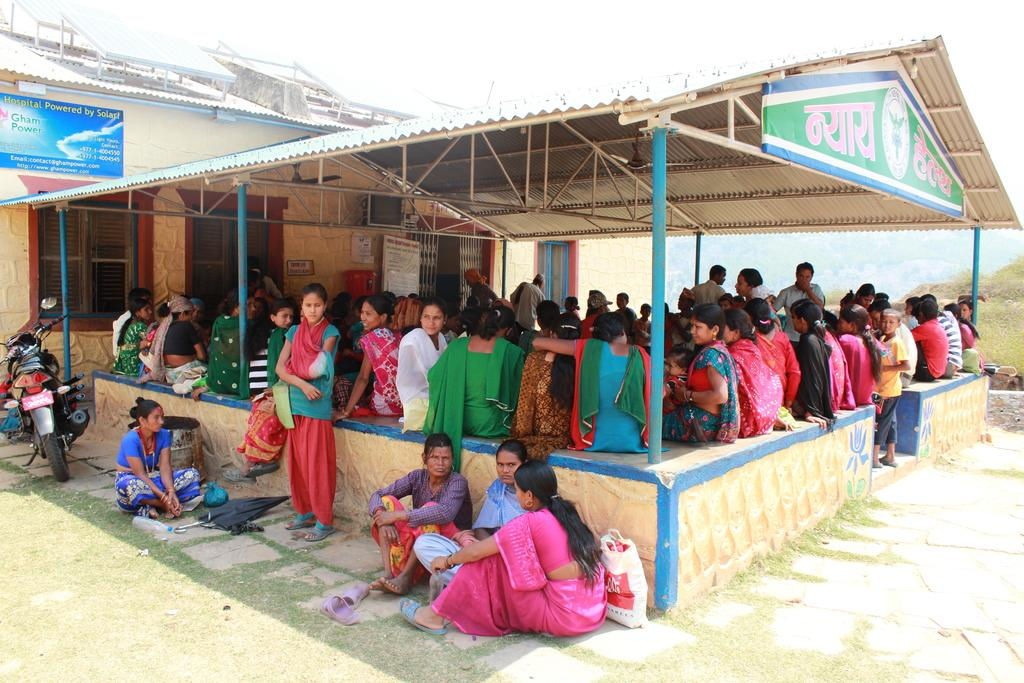What type of space is depicted in the image? There is a hall in the image. What are the people in the hall doing? There is a group of people sitting on a fence in the hall. What can be seen in the background of the image? The sky is visible in the image. What objects are present in the hall? There are boards in the image. When was the image taken? The image was taken during the day. What type of bucket is being used to rub the plates in the image? There is no bucket or rubbing of plates present in the image. 